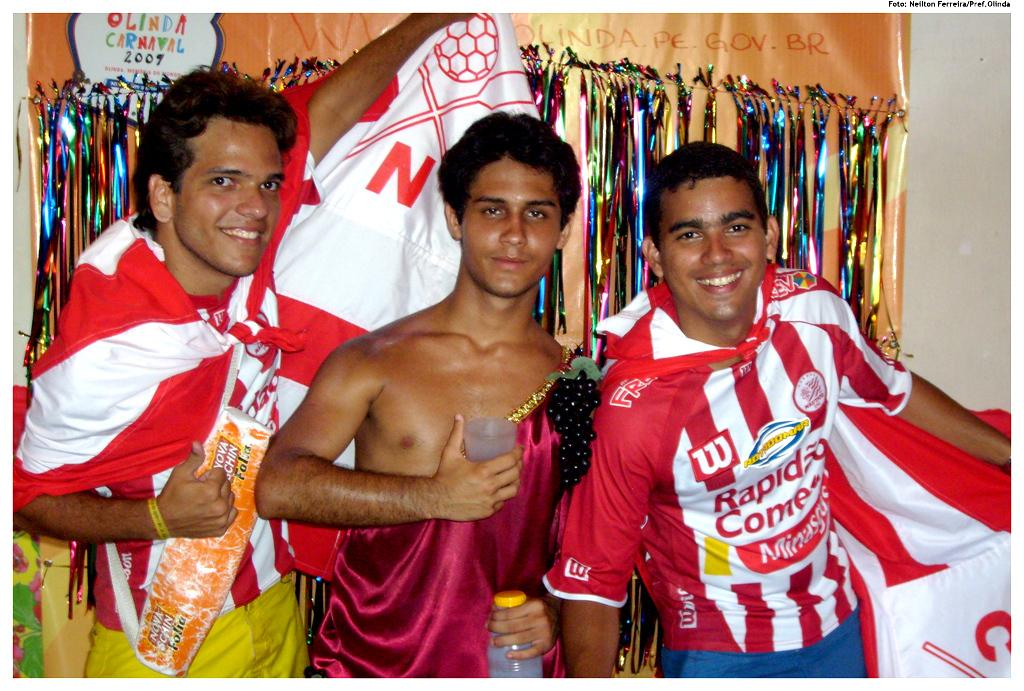Provide a one-sentence caption for the provided image. A group of men celebrate together for the team Rapid Come. 